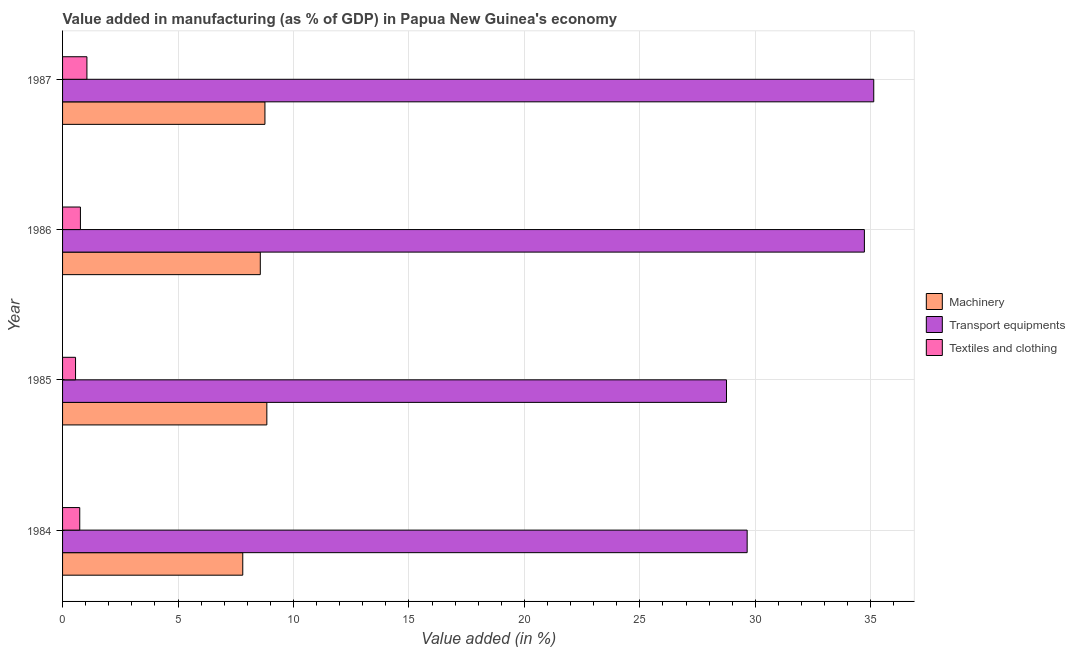How many different coloured bars are there?
Offer a very short reply. 3. How many groups of bars are there?
Provide a succinct answer. 4. Are the number of bars per tick equal to the number of legend labels?
Your response must be concise. Yes. Are the number of bars on each tick of the Y-axis equal?
Provide a succinct answer. Yes. In how many cases, is the number of bars for a given year not equal to the number of legend labels?
Give a very brief answer. 0. What is the value added in manufacturing machinery in 1984?
Offer a terse response. 7.8. Across all years, what is the maximum value added in manufacturing machinery?
Your response must be concise. 8.85. Across all years, what is the minimum value added in manufacturing transport equipments?
Your answer should be very brief. 28.75. In which year was the value added in manufacturing transport equipments maximum?
Provide a succinct answer. 1987. What is the total value added in manufacturing machinery in the graph?
Your response must be concise. 33.98. What is the difference between the value added in manufacturing machinery in 1985 and that in 1987?
Make the answer very short. 0.08. What is the difference between the value added in manufacturing textile and clothing in 1987 and the value added in manufacturing transport equipments in 1986?
Your answer should be very brief. -33.67. What is the average value added in manufacturing transport equipments per year?
Make the answer very short. 32.06. In the year 1985, what is the difference between the value added in manufacturing machinery and value added in manufacturing textile and clothing?
Your response must be concise. 8.29. What is the ratio of the value added in manufacturing transport equipments in 1984 to that in 1987?
Your answer should be compact. 0.84. Is the value added in manufacturing machinery in 1985 less than that in 1986?
Give a very brief answer. No. What is the difference between the highest and the second highest value added in manufacturing machinery?
Offer a very short reply. 0.08. What is the difference between the highest and the lowest value added in manufacturing textile and clothing?
Your answer should be very brief. 0.49. Is the sum of the value added in manufacturing machinery in 1985 and 1987 greater than the maximum value added in manufacturing textile and clothing across all years?
Give a very brief answer. Yes. What does the 2nd bar from the top in 1986 represents?
Your response must be concise. Transport equipments. What does the 1st bar from the bottom in 1986 represents?
Your response must be concise. Machinery. Are all the bars in the graph horizontal?
Give a very brief answer. Yes. What is the difference between two consecutive major ticks on the X-axis?
Ensure brevity in your answer.  5. Are the values on the major ticks of X-axis written in scientific E-notation?
Offer a terse response. No. How many legend labels are there?
Give a very brief answer. 3. How are the legend labels stacked?
Provide a short and direct response. Vertical. What is the title of the graph?
Provide a succinct answer. Value added in manufacturing (as % of GDP) in Papua New Guinea's economy. What is the label or title of the X-axis?
Provide a short and direct response. Value added (in %). What is the label or title of the Y-axis?
Offer a very short reply. Year. What is the Value added (in %) in Machinery in 1984?
Offer a terse response. 7.8. What is the Value added (in %) of Transport equipments in 1984?
Provide a succinct answer. 29.65. What is the Value added (in %) of Textiles and clothing in 1984?
Your answer should be compact. 0.74. What is the Value added (in %) in Machinery in 1985?
Give a very brief answer. 8.85. What is the Value added (in %) in Transport equipments in 1985?
Your answer should be compact. 28.75. What is the Value added (in %) in Textiles and clothing in 1985?
Your response must be concise. 0.56. What is the Value added (in %) of Machinery in 1986?
Your answer should be very brief. 8.56. What is the Value added (in %) in Transport equipments in 1986?
Provide a short and direct response. 34.73. What is the Value added (in %) of Textiles and clothing in 1986?
Your answer should be very brief. 0.77. What is the Value added (in %) in Machinery in 1987?
Provide a short and direct response. 8.76. What is the Value added (in %) in Transport equipments in 1987?
Your answer should be compact. 35.13. What is the Value added (in %) in Textiles and clothing in 1987?
Your response must be concise. 1.05. Across all years, what is the maximum Value added (in %) in Machinery?
Ensure brevity in your answer.  8.85. Across all years, what is the maximum Value added (in %) of Transport equipments?
Give a very brief answer. 35.13. Across all years, what is the maximum Value added (in %) in Textiles and clothing?
Make the answer very short. 1.05. Across all years, what is the minimum Value added (in %) in Machinery?
Your answer should be very brief. 7.8. Across all years, what is the minimum Value added (in %) in Transport equipments?
Your response must be concise. 28.75. Across all years, what is the minimum Value added (in %) of Textiles and clothing?
Offer a terse response. 0.56. What is the total Value added (in %) in Machinery in the graph?
Your response must be concise. 33.98. What is the total Value added (in %) in Transport equipments in the graph?
Offer a terse response. 128.26. What is the total Value added (in %) of Textiles and clothing in the graph?
Give a very brief answer. 3.13. What is the difference between the Value added (in %) in Machinery in 1984 and that in 1985?
Your answer should be compact. -1.04. What is the difference between the Value added (in %) of Transport equipments in 1984 and that in 1985?
Ensure brevity in your answer.  0.9. What is the difference between the Value added (in %) in Textiles and clothing in 1984 and that in 1985?
Make the answer very short. 0.18. What is the difference between the Value added (in %) of Machinery in 1984 and that in 1986?
Offer a very short reply. -0.76. What is the difference between the Value added (in %) in Transport equipments in 1984 and that in 1986?
Offer a terse response. -5.08. What is the difference between the Value added (in %) of Textiles and clothing in 1984 and that in 1986?
Keep it short and to the point. -0.03. What is the difference between the Value added (in %) of Machinery in 1984 and that in 1987?
Keep it short and to the point. -0.96. What is the difference between the Value added (in %) in Transport equipments in 1984 and that in 1987?
Provide a short and direct response. -5.48. What is the difference between the Value added (in %) of Textiles and clothing in 1984 and that in 1987?
Offer a terse response. -0.31. What is the difference between the Value added (in %) of Machinery in 1985 and that in 1986?
Provide a succinct answer. 0.28. What is the difference between the Value added (in %) in Transport equipments in 1985 and that in 1986?
Your answer should be very brief. -5.97. What is the difference between the Value added (in %) of Textiles and clothing in 1985 and that in 1986?
Make the answer very short. -0.21. What is the difference between the Value added (in %) of Machinery in 1985 and that in 1987?
Keep it short and to the point. 0.08. What is the difference between the Value added (in %) of Transport equipments in 1985 and that in 1987?
Your response must be concise. -6.38. What is the difference between the Value added (in %) of Textiles and clothing in 1985 and that in 1987?
Ensure brevity in your answer.  -0.49. What is the difference between the Value added (in %) of Machinery in 1986 and that in 1987?
Offer a terse response. -0.2. What is the difference between the Value added (in %) in Transport equipments in 1986 and that in 1987?
Ensure brevity in your answer.  -0.41. What is the difference between the Value added (in %) in Textiles and clothing in 1986 and that in 1987?
Provide a short and direct response. -0.28. What is the difference between the Value added (in %) of Machinery in 1984 and the Value added (in %) of Transport equipments in 1985?
Ensure brevity in your answer.  -20.95. What is the difference between the Value added (in %) of Machinery in 1984 and the Value added (in %) of Textiles and clothing in 1985?
Keep it short and to the point. 7.24. What is the difference between the Value added (in %) of Transport equipments in 1984 and the Value added (in %) of Textiles and clothing in 1985?
Keep it short and to the point. 29.09. What is the difference between the Value added (in %) of Machinery in 1984 and the Value added (in %) of Transport equipments in 1986?
Make the answer very short. -26.92. What is the difference between the Value added (in %) of Machinery in 1984 and the Value added (in %) of Textiles and clothing in 1986?
Ensure brevity in your answer.  7.03. What is the difference between the Value added (in %) in Transport equipments in 1984 and the Value added (in %) in Textiles and clothing in 1986?
Keep it short and to the point. 28.88. What is the difference between the Value added (in %) of Machinery in 1984 and the Value added (in %) of Transport equipments in 1987?
Provide a succinct answer. -27.33. What is the difference between the Value added (in %) of Machinery in 1984 and the Value added (in %) of Textiles and clothing in 1987?
Your answer should be very brief. 6.75. What is the difference between the Value added (in %) in Transport equipments in 1984 and the Value added (in %) in Textiles and clothing in 1987?
Offer a very short reply. 28.59. What is the difference between the Value added (in %) in Machinery in 1985 and the Value added (in %) in Transport equipments in 1986?
Provide a succinct answer. -25.88. What is the difference between the Value added (in %) of Machinery in 1985 and the Value added (in %) of Textiles and clothing in 1986?
Give a very brief answer. 8.07. What is the difference between the Value added (in %) of Transport equipments in 1985 and the Value added (in %) of Textiles and clothing in 1986?
Your answer should be very brief. 27.98. What is the difference between the Value added (in %) in Machinery in 1985 and the Value added (in %) in Transport equipments in 1987?
Offer a terse response. -26.28. What is the difference between the Value added (in %) in Machinery in 1985 and the Value added (in %) in Textiles and clothing in 1987?
Your answer should be very brief. 7.79. What is the difference between the Value added (in %) in Transport equipments in 1985 and the Value added (in %) in Textiles and clothing in 1987?
Your answer should be very brief. 27.7. What is the difference between the Value added (in %) of Machinery in 1986 and the Value added (in %) of Transport equipments in 1987?
Offer a terse response. -26.57. What is the difference between the Value added (in %) in Machinery in 1986 and the Value added (in %) in Textiles and clothing in 1987?
Ensure brevity in your answer.  7.51. What is the difference between the Value added (in %) of Transport equipments in 1986 and the Value added (in %) of Textiles and clothing in 1987?
Ensure brevity in your answer.  33.67. What is the average Value added (in %) in Machinery per year?
Your answer should be compact. 8.49. What is the average Value added (in %) in Transport equipments per year?
Your answer should be very brief. 32.06. What is the average Value added (in %) in Textiles and clothing per year?
Your response must be concise. 0.78. In the year 1984, what is the difference between the Value added (in %) of Machinery and Value added (in %) of Transport equipments?
Offer a very short reply. -21.84. In the year 1984, what is the difference between the Value added (in %) in Machinery and Value added (in %) in Textiles and clothing?
Keep it short and to the point. 7.06. In the year 1984, what is the difference between the Value added (in %) in Transport equipments and Value added (in %) in Textiles and clothing?
Provide a succinct answer. 28.9. In the year 1985, what is the difference between the Value added (in %) in Machinery and Value added (in %) in Transport equipments?
Offer a very short reply. -19.91. In the year 1985, what is the difference between the Value added (in %) in Machinery and Value added (in %) in Textiles and clothing?
Provide a short and direct response. 8.29. In the year 1985, what is the difference between the Value added (in %) of Transport equipments and Value added (in %) of Textiles and clothing?
Offer a very short reply. 28.19. In the year 1986, what is the difference between the Value added (in %) in Machinery and Value added (in %) in Transport equipments?
Your answer should be very brief. -26.16. In the year 1986, what is the difference between the Value added (in %) in Machinery and Value added (in %) in Textiles and clothing?
Your answer should be very brief. 7.79. In the year 1986, what is the difference between the Value added (in %) in Transport equipments and Value added (in %) in Textiles and clothing?
Keep it short and to the point. 33.95. In the year 1987, what is the difference between the Value added (in %) in Machinery and Value added (in %) in Transport equipments?
Make the answer very short. -26.37. In the year 1987, what is the difference between the Value added (in %) in Machinery and Value added (in %) in Textiles and clothing?
Your answer should be compact. 7.71. In the year 1987, what is the difference between the Value added (in %) of Transport equipments and Value added (in %) of Textiles and clothing?
Provide a short and direct response. 34.08. What is the ratio of the Value added (in %) of Machinery in 1984 to that in 1985?
Provide a short and direct response. 0.88. What is the ratio of the Value added (in %) of Transport equipments in 1984 to that in 1985?
Your answer should be very brief. 1.03. What is the ratio of the Value added (in %) in Textiles and clothing in 1984 to that in 1985?
Keep it short and to the point. 1.32. What is the ratio of the Value added (in %) of Machinery in 1984 to that in 1986?
Your response must be concise. 0.91. What is the ratio of the Value added (in %) of Transport equipments in 1984 to that in 1986?
Offer a terse response. 0.85. What is the ratio of the Value added (in %) of Textiles and clothing in 1984 to that in 1986?
Offer a terse response. 0.96. What is the ratio of the Value added (in %) of Machinery in 1984 to that in 1987?
Make the answer very short. 0.89. What is the ratio of the Value added (in %) of Transport equipments in 1984 to that in 1987?
Your answer should be very brief. 0.84. What is the ratio of the Value added (in %) of Textiles and clothing in 1984 to that in 1987?
Provide a succinct answer. 0.71. What is the ratio of the Value added (in %) of Machinery in 1985 to that in 1986?
Provide a short and direct response. 1.03. What is the ratio of the Value added (in %) in Transport equipments in 1985 to that in 1986?
Ensure brevity in your answer.  0.83. What is the ratio of the Value added (in %) in Textiles and clothing in 1985 to that in 1986?
Give a very brief answer. 0.73. What is the ratio of the Value added (in %) of Machinery in 1985 to that in 1987?
Offer a very short reply. 1.01. What is the ratio of the Value added (in %) in Transport equipments in 1985 to that in 1987?
Give a very brief answer. 0.82. What is the ratio of the Value added (in %) of Textiles and clothing in 1985 to that in 1987?
Provide a succinct answer. 0.53. What is the ratio of the Value added (in %) in Machinery in 1986 to that in 1987?
Keep it short and to the point. 0.98. What is the ratio of the Value added (in %) in Transport equipments in 1986 to that in 1987?
Ensure brevity in your answer.  0.99. What is the ratio of the Value added (in %) in Textiles and clothing in 1986 to that in 1987?
Provide a short and direct response. 0.73. What is the difference between the highest and the second highest Value added (in %) in Machinery?
Offer a very short reply. 0.08. What is the difference between the highest and the second highest Value added (in %) in Transport equipments?
Offer a terse response. 0.41. What is the difference between the highest and the second highest Value added (in %) in Textiles and clothing?
Offer a very short reply. 0.28. What is the difference between the highest and the lowest Value added (in %) in Machinery?
Offer a very short reply. 1.04. What is the difference between the highest and the lowest Value added (in %) in Transport equipments?
Your answer should be very brief. 6.38. What is the difference between the highest and the lowest Value added (in %) of Textiles and clothing?
Offer a very short reply. 0.49. 